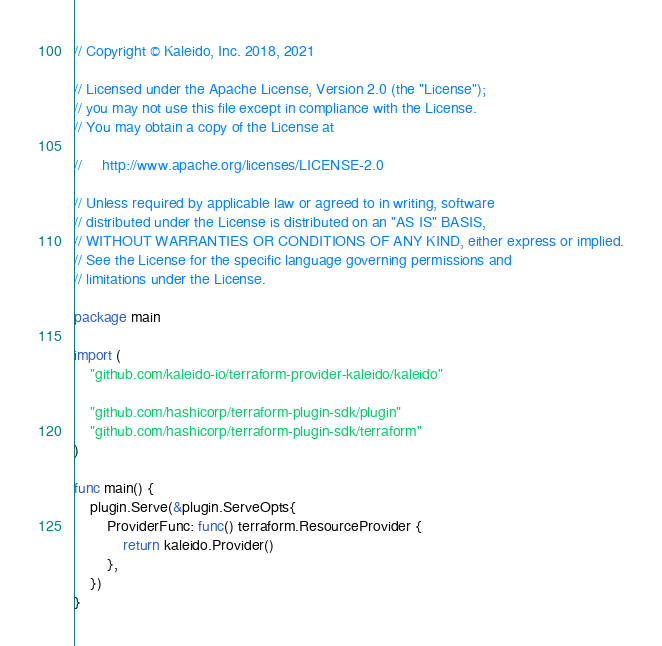Convert code to text. <code><loc_0><loc_0><loc_500><loc_500><_Go_>// Copyright © Kaleido, Inc. 2018, 2021

// Licensed under the Apache License, Version 2.0 (the "License");
// you may not use this file except in compliance with the License.
// You may obtain a copy of the License at

//     http://www.apache.org/licenses/LICENSE-2.0

// Unless required by applicable law or agreed to in writing, software
// distributed under the License is distributed on an "AS IS" BASIS,
// WITHOUT WARRANTIES OR CONDITIONS OF ANY KIND, either express or implied.
// See the License for the specific language governing permissions and
// limitations under the License.

package main

import (
	"github.com/kaleido-io/terraform-provider-kaleido/kaleido"

	"github.com/hashicorp/terraform-plugin-sdk/plugin"
	"github.com/hashicorp/terraform-plugin-sdk/terraform"
)

func main() {
	plugin.Serve(&plugin.ServeOpts{
		ProviderFunc: func() terraform.ResourceProvider {
			return kaleido.Provider()
		},
	})
}
</code> 